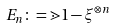Convert formula to latex. <formula><loc_0><loc_0><loc_500><loc_500>E _ { n } \colon = { \mathbb { m } { 1 } } - \xi ^ { \otimes n }</formula> 